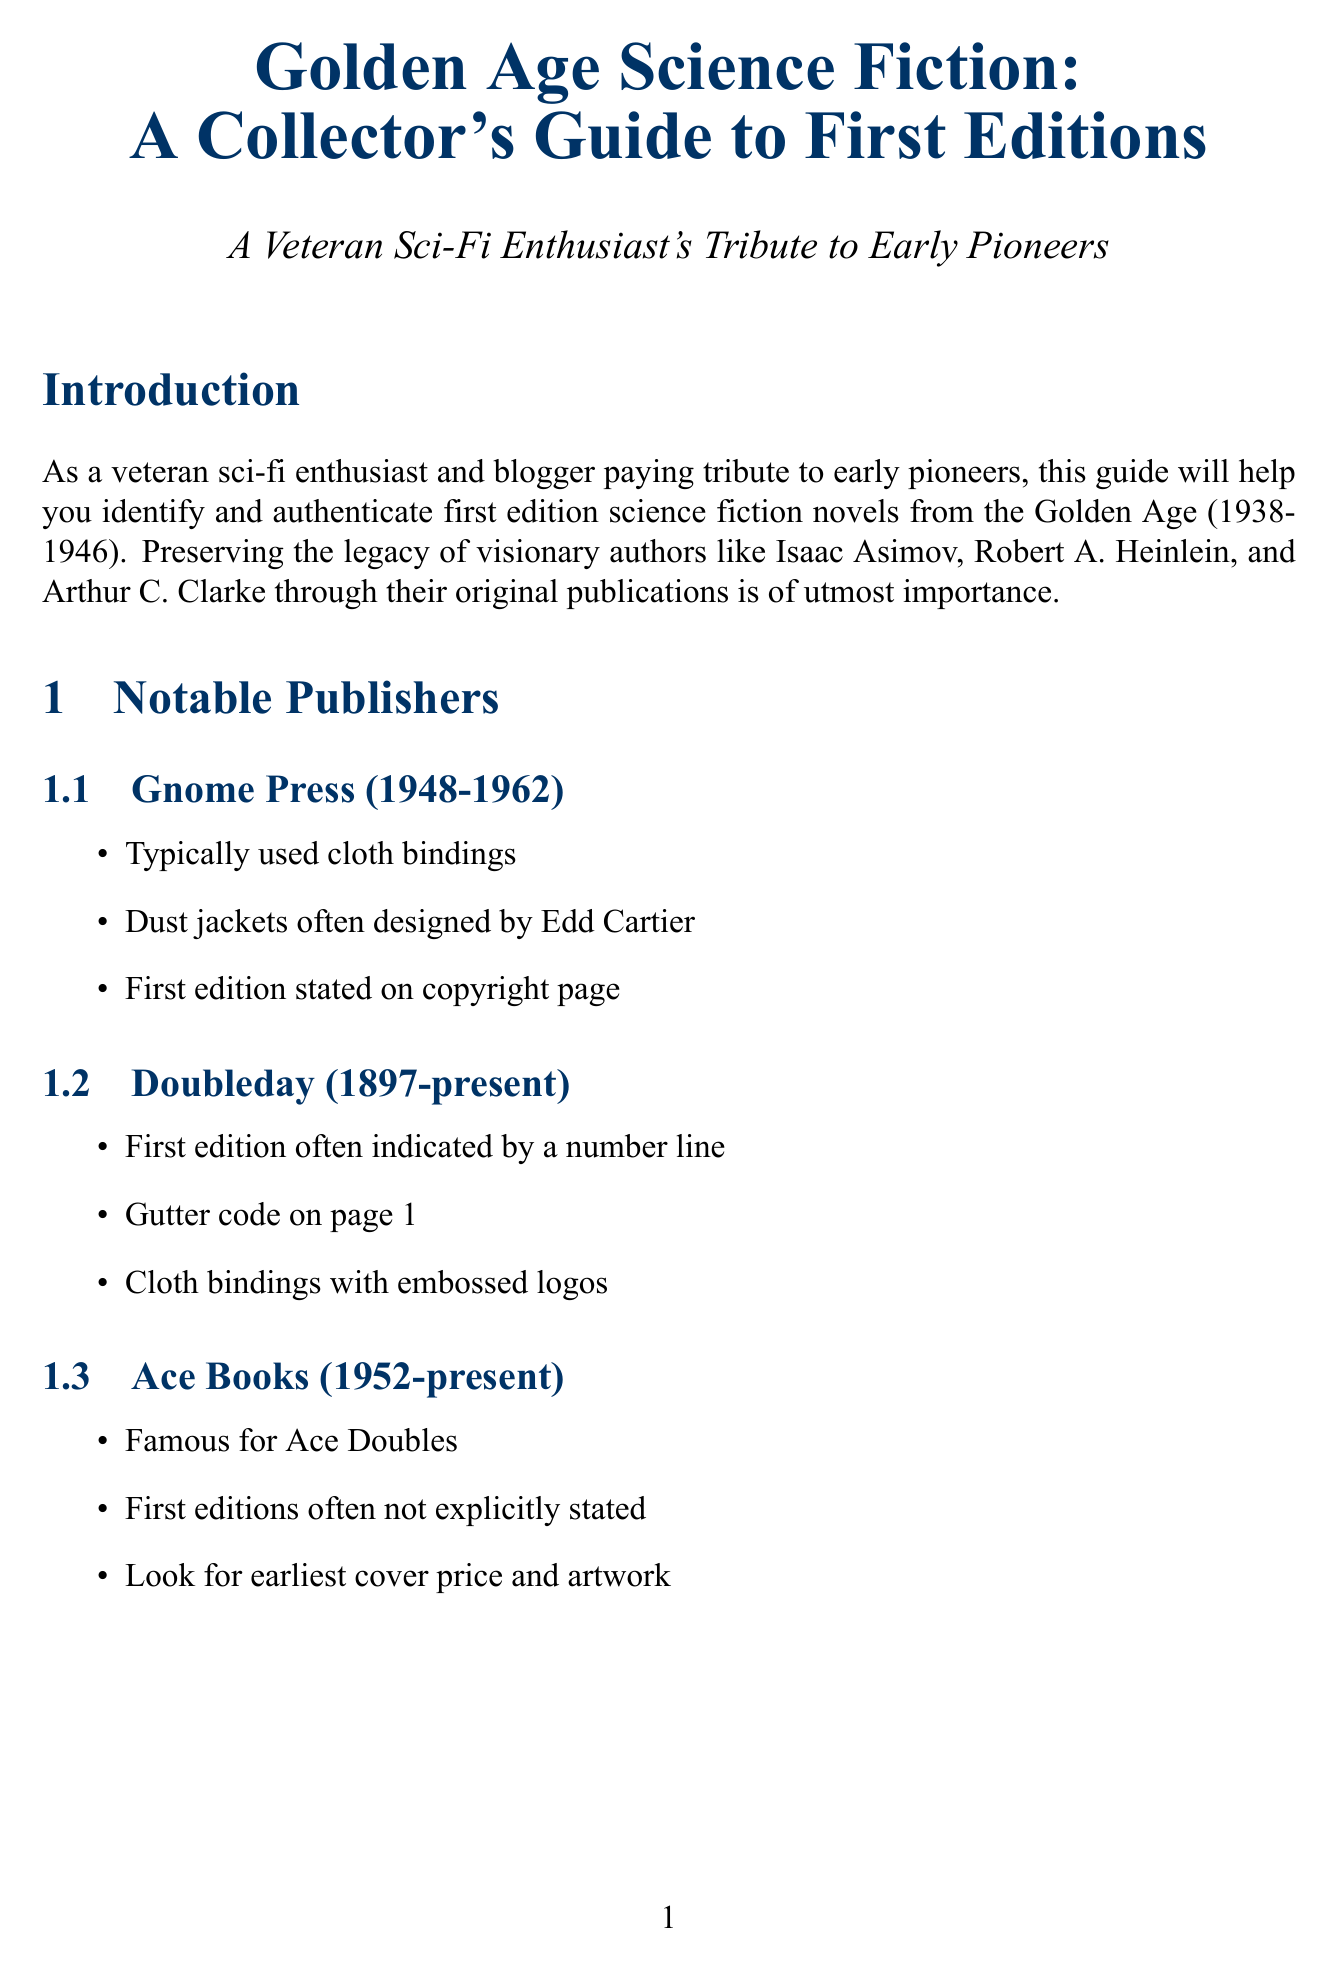What years did Gnome Press operate? Gnome Press operated from 1948 to 1962 as mentioned in the "Notable Publishers" section.
Answer: 1948-1962 What feature on the copyright page often indicates a first edition? The copyright page often contains an explicit first edition statement or number line, as stated in the "Identifying Marks" section.
Answer: Number line Which binding style is most common for hardcover first editions? The "Binding Styles" section indicates that cloth binding is the most common style.
Answer: Cloth binding What is a common misconception about first editions regarding value? The document mentions that some later editions can be more valuable than first editions, which addresses the misconception under "Common Misconceptions."
Answer: First editions are always the most valuable What location houses the Forrest J. Ackerman Collection? The document specifies that the Forrest J. Ackerman Collection is located at the Science Fiction Museum and Hall of Fame, Seattle.
Answer: Seattle What publisher is known for Ace Doubles? According to the "Notable Publishers" section, Ace Books is famous for Ace Doubles.
Answer: Ace Books What is a preservation tip provided in the document? One of the preservation tips listed states that books should be stored away from direct sunlight, highlighting its importance in the "Preservation Tips" section.
Answer: Away from direct sunlight Which author wrote "Foundation"? The document specifies that Isaac Asimov wrote "Foundation," which is an example under cloth binding.
Answer: Isaac Asimov What design element is often found on the dust jackets from Gnome Press? The document notes that dust jackets from Gnome Press are often designed by Edd Cartier, as mentioned in the "Notable Publishers" section.
Answer: Edd Cartier 